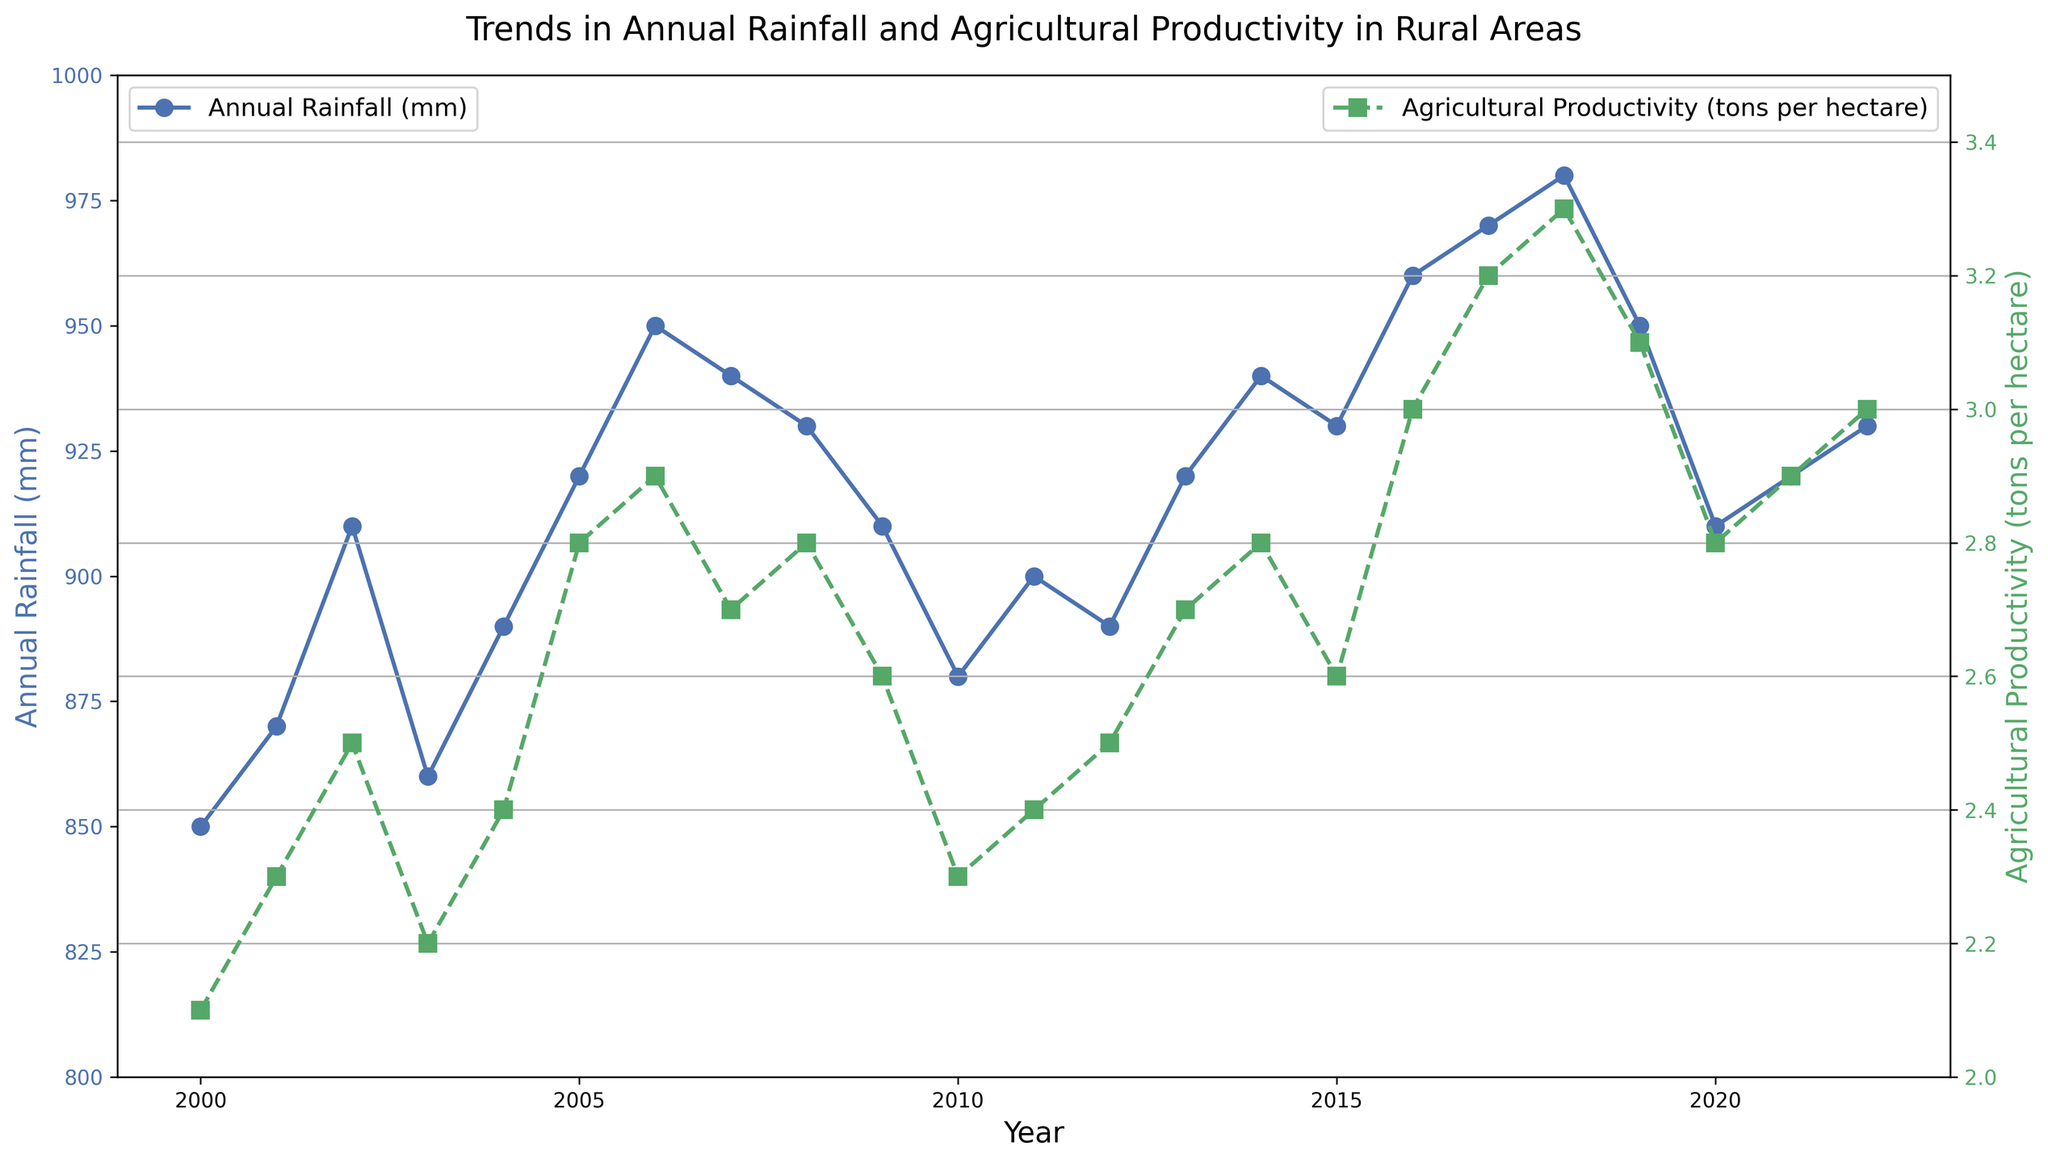Which year had the highest rainfall? From the plot, identify the point on the 'Annual Rainfall (mm)' line that is at the maximum height. The year corresponding to this point is the one with the highest rainfall.
Answer: 2018 What is the difference in productivity between 2016 and 2018? Check the 'Agricultural Productivity (tons per hectare)' value for 2016, which is 3.0, and for 2018, which is 3.3. The difference is calculated as 3.3 - 3.0.
Answer: 0.3 tons per hectare How did the agricultural productivity change from 2005 to 2006? Look at the 'Agricultural Productivity (tons per hectare)' line for 2005, which is 2.8, and for 2006, which is 2.9. The change can be found as 2.9 - 2.8.
Answer: Increased by 0.1 When did the rainfall and productivity both show a declining trend from the previous year? Examine both lines together. In 2009, both 'Annual Rainfall (mm)' and 'Agricultural Productivity (tons per hectare)' decrease from their values in 2008.
Answer: 2009 By how much did the agricultural productivity differ between the year with the highest rainfall and the year with the lowest productivity? Identify 2018 as the year with the highest rainfall (980 mm) and 2000 as the year with the lowest productivity (2.1 tons per hectare). From the plot, the productivity in 2018 was 3.3 tons per hectare. The difference is 3.3 - 2.1.
Answer: 1.2 tons per hectare Is there a general trend between rainfall and productivity? Observe the overall direction and patterns of both lines. Generally, higher rainfall corresponds with higher agricultural productivity, indicating a positive correlation.
Answer: Positive correlation What is the range of annual rainfall observed in the data? Identify the minimum and maximum values of 'Annual Rainfall (mm)' in the plot. The minimum is 850 mm (2000) and the maximum is 980 mm (2018). The range is found by subtracting the minimum from the maximum.
Answer: 130 mm Compare the number of years with increasing productivity to those with decreasing productivity from 2000 to 2022. Count the years where the 'Agricultural Productivity (tons per hectare)' line increases from the previous year and compare to those where it decreases. Count the years with rises: 12 (years: 2001, 2002, 2004, 2005, 2006, 2008, 2010, 2013, 2016, 2017, 2019, 2021). Count the years with falls: 8 (years: 2003, 2007, 2009, 2012, 2015, 2018, 2020, 2022).
Answer: Increases: 12, Decreases: 8 